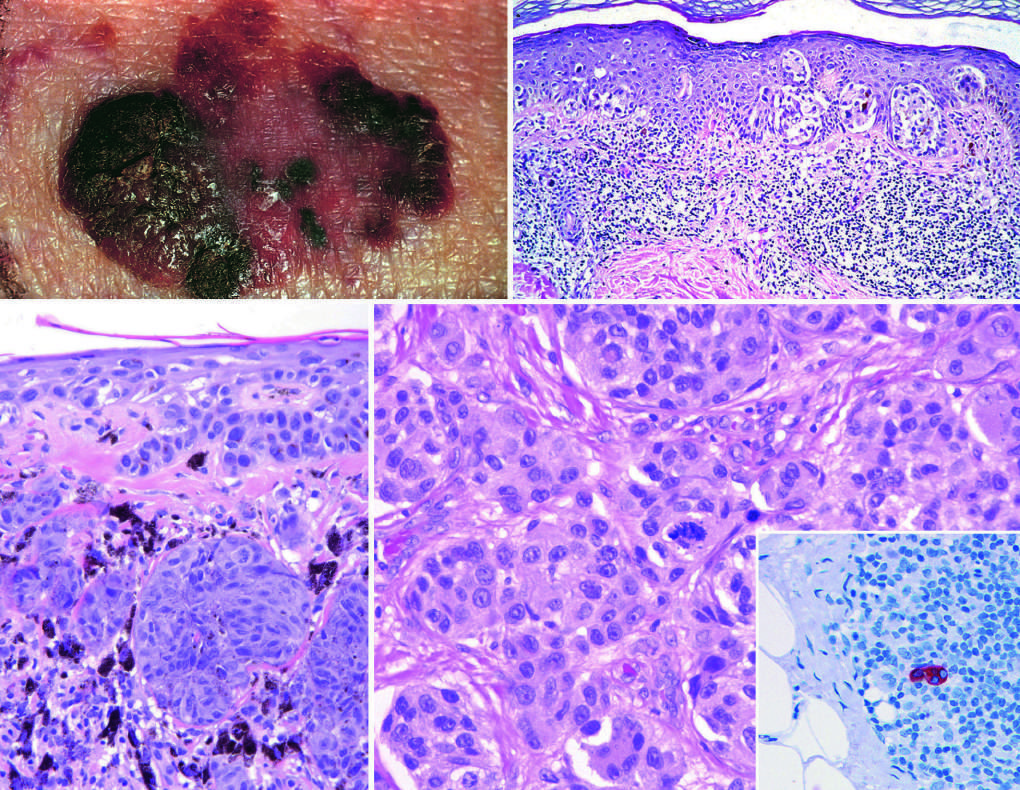what is present in the center of the field?
Answer the question using a single word or phrase. An atypical mitotic figure 